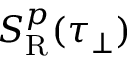Convert formula to latex. <formula><loc_0><loc_0><loc_500><loc_500>S _ { R } ^ { p } ( \tau _ { \perp } )</formula> 